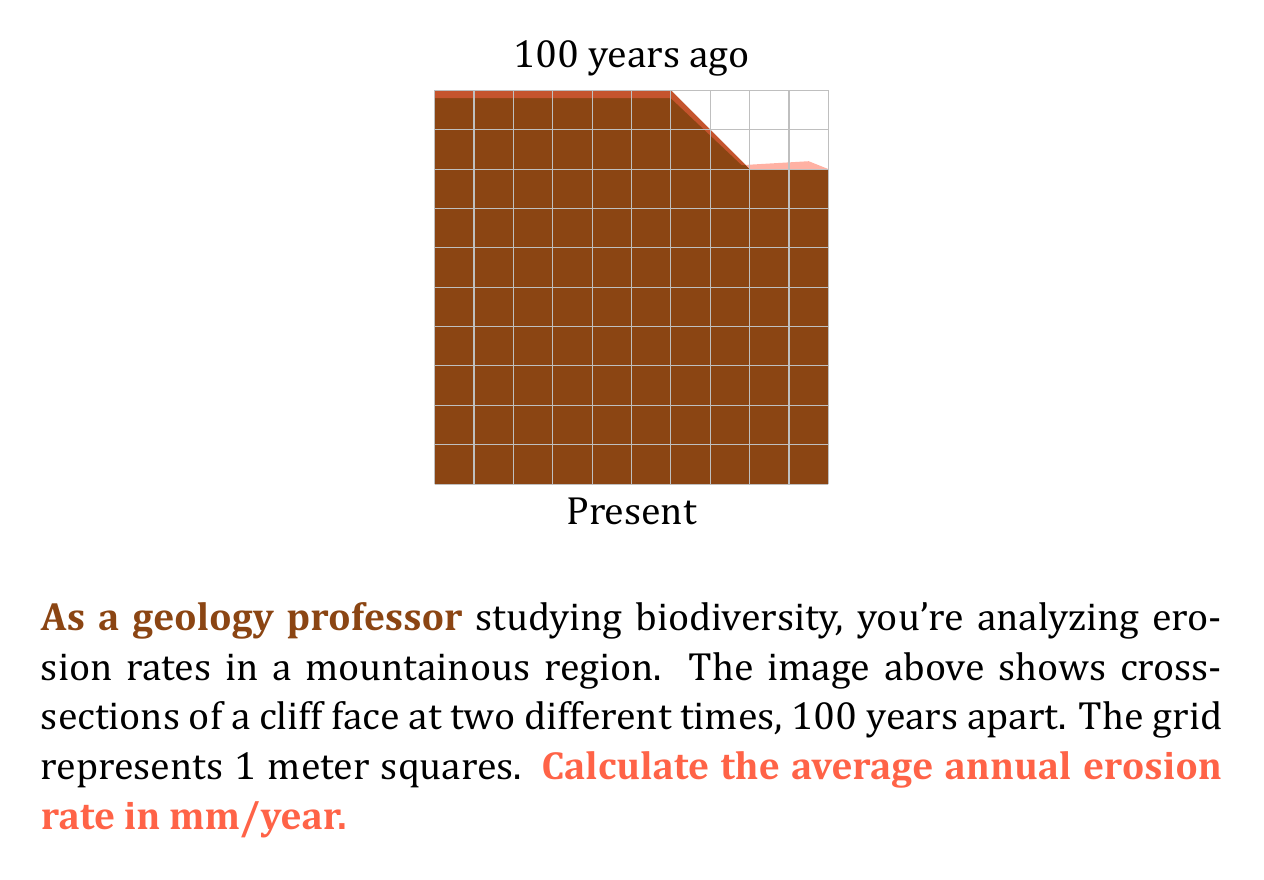Help me with this question. To solve this problem, we'll follow these steps:

1) First, we need to estimate the area of erosion from the image. The eroded area appears to be approximately 2 square meters (2 grid squares).

2) To calculate the average depth of erosion, we divide the eroded area by the width of the cliff face:

   $$ \text{Average Depth} = \frac{\text{Eroded Area}}{\text{Cliff Width}} = \frac{2 \text{ m}^2}{10 \text{ m}} = 0.2 \text{ m} $$

3) Now we have the erosion depth over 100 years. To find the annual rate, we divide by 100:

   $$ \text{Annual Erosion Rate} = \frac{0.2 \text{ m}}{100 \text{ years}} = 0.002 \text{ m/year} $$

4) The question asks for the rate in mm/year, so we convert meters to millimeters:

   $$ 0.002 \text{ m/year} \times \frac{1000 \text{ mm}}{1 \text{ m}} = 2 \text{ mm/year} $$

Therefore, the average annual erosion rate is 2 mm/year.
Answer: 2 mm/year 